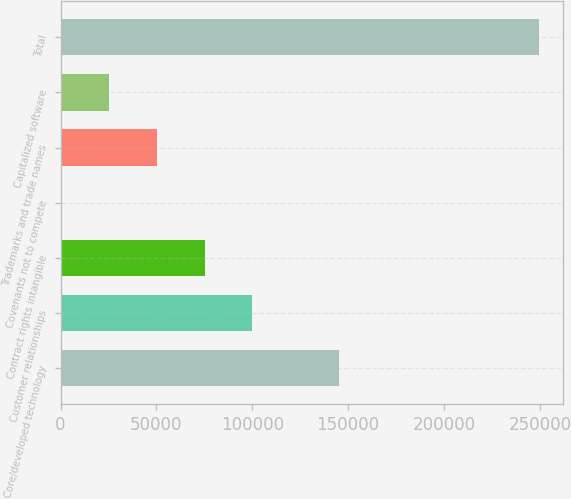Convert chart. <chart><loc_0><loc_0><loc_500><loc_500><bar_chart><fcel>Core/developed technology<fcel>Customer relationships<fcel>Contract rights intangible<fcel>Covenants not to compete<fcel>Trademarks and trade names<fcel>Capitalized software<fcel>Total<nl><fcel>145005<fcel>100052<fcel>75118<fcel>316<fcel>50184<fcel>25250<fcel>249656<nl></chart> 